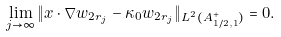<formula> <loc_0><loc_0><loc_500><loc_500>\lim _ { j \rightarrow \infty } \| x \cdot \nabla w _ { 2 r _ { j } } - \kappa _ { 0 } w _ { 2 r _ { j } } \| _ { L ^ { 2 } ( A _ { 1 / 2 , 1 } ^ { + } ) } = 0 .</formula> 